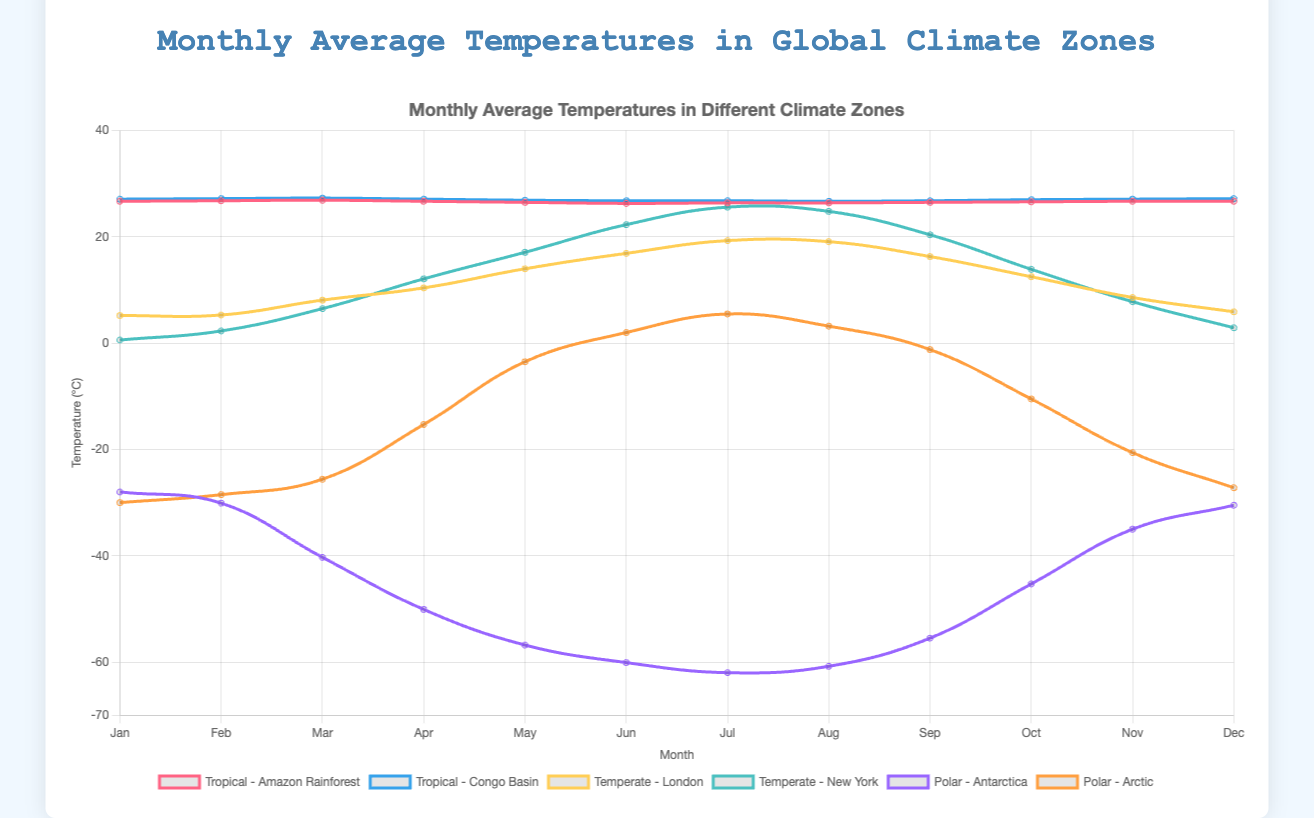Which zone has the highest average temperature in January? To find the highest average temperature in January, compare the January temperatures across all regions. The Congo Basin (Tropical zone) has the highest January average temperature of 27.1°C.
Answer: Congo Basin, Tropical zone In which month does New York experience the highest average temperature, and what is the temperature? Look at the temperature values for New York across all months and identify the highest value. New York's highest average temperature is 25.6°C, which occurs in July.
Answer: July, 25.6°C Which region has the lowest average temperature in June? Compare the June temperatures across all regions. Antarctica in the Polar zone has the lowest June average temperature of -60.1°C.
Answer: Antarctica, Polar zone What is the temperature difference between January and July in the Arctic? Subtract the January temperature in the Arctic from the July temperature in the Arctic. The difference is 5.5°C - (-30.0°C) = 35.5°C.
Answer: 35.5°C How much higher is the average temperature in July in the Amazon Rainforest compared to the average temperature in the Congo Basin in July? Subtract the Congo Basin temperature in July from the Amazon Rainforest temperature in July. The difference is 26.4°C - 26.8°C = -0.4°C, meaning the Amazon Rainforest is 0.4°C cooler.
Answer: -0.4°C Which temperate region experiences a greater temperature variation between December and June? Calculate the temperature differences between December and June for London and New York. London: 16.9°C - 5.9°C = 11°C; New York: 22.3°C - 2.9°C = 19.4°C. New York has a greater variation of 19.4°C.
Answer: New York What is the average temperature for the Arctic region across the entire year? Sum all monthly temperatures for the Arctic region and divide by 12. The sum is -208.1°C. The average yearly temperature = -208.1°C / 12 ≈ -17.34°C.
Answer: -17.34°C Which month has the highest average temperature in the Tropical zone? Compare the monthly temperatures in the Amazon Rainforest and Congo Basin to determine which month has the highest average across both regions. The highest value is 27.3°C in March in the Congo Basin.
Answer: March How do the temperature trends in the Tropical and Polar zones differ over the year? Observing the lines for Tropical and Polar zones, Tropical temperatures stay relatively stable ~26-27°C, whereas Polar temperatures vary significantly from -62°C to 5.5°C. Tropical zones have stable, high temperatures, and Polar zones have high variability and lower temperatures.
Answer: Tropical: stable, high; Polar: variable, lower What is the difference in temperature between London and New York in October and which city is warmer? Subtract London's October temperature from New York's October temperature. The difference is 13.9°C - 12.5°C = 1.4°C, making New York warmer by 1.4°C.
Answer: New York, 1.4°C warmer 